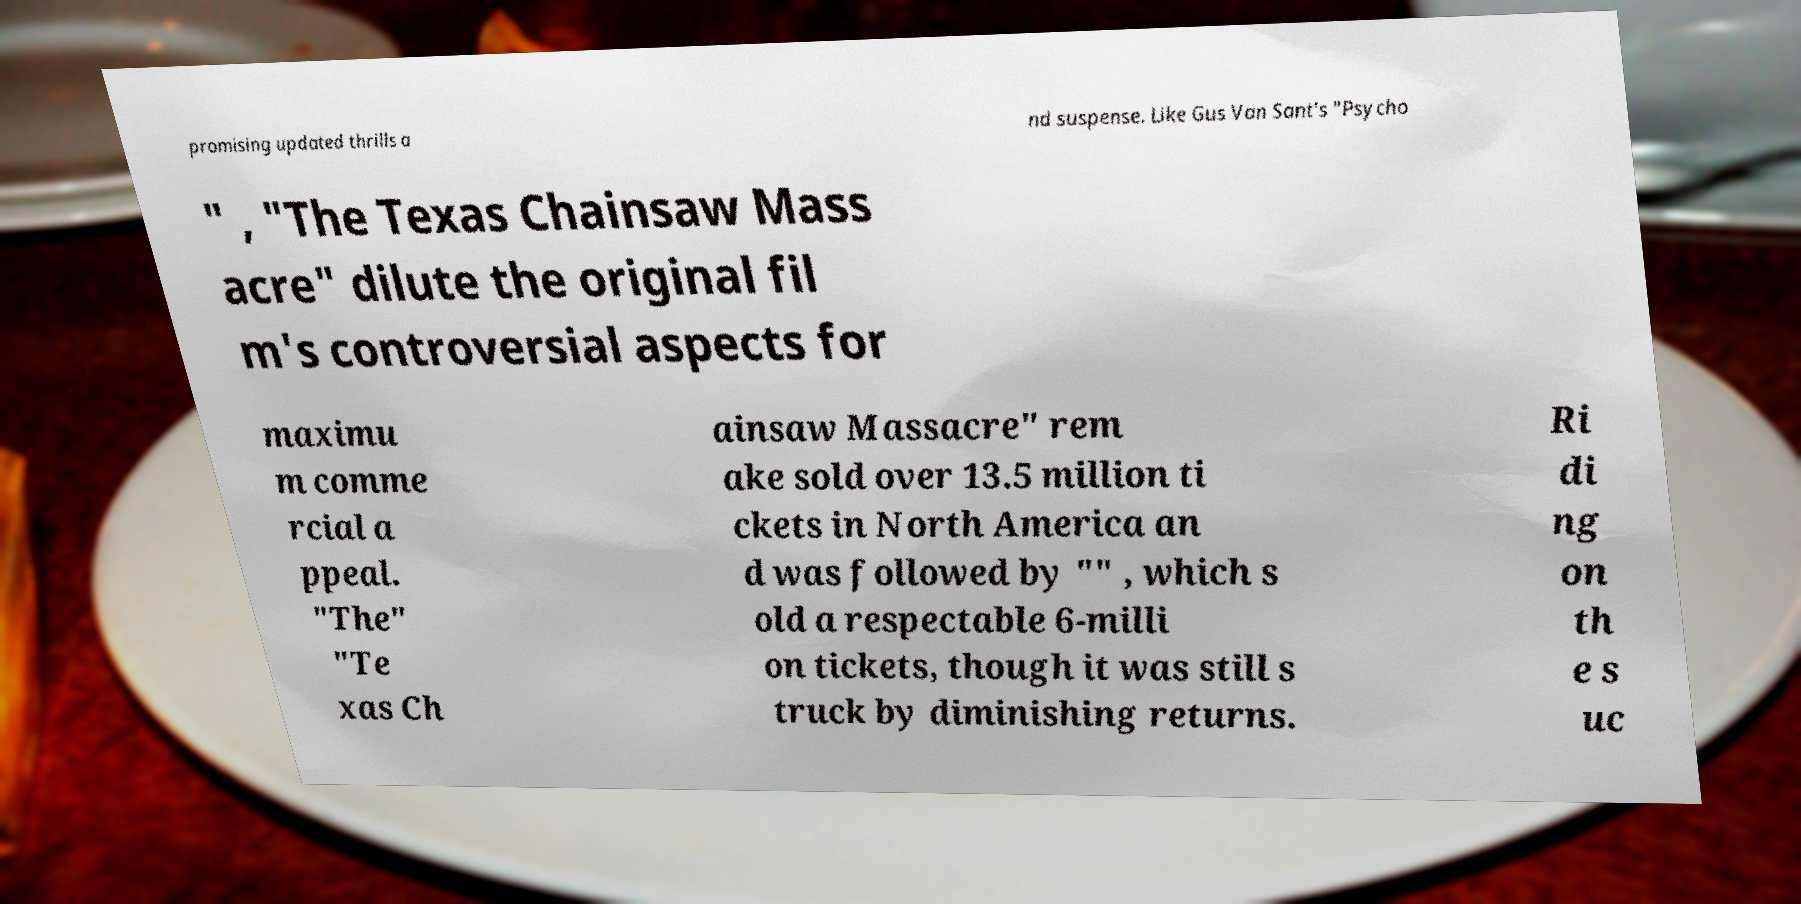I need the written content from this picture converted into text. Can you do that? promising updated thrills a nd suspense. Like Gus Van Sant's "Psycho " , "The Texas Chainsaw Mass acre" dilute the original fil m's controversial aspects for maximu m comme rcial a ppeal. "The" "Te xas Ch ainsaw Massacre" rem ake sold over 13.5 million ti ckets in North America an d was followed by "" , which s old a respectable 6-milli on tickets, though it was still s truck by diminishing returns. Ri di ng on th e s uc 